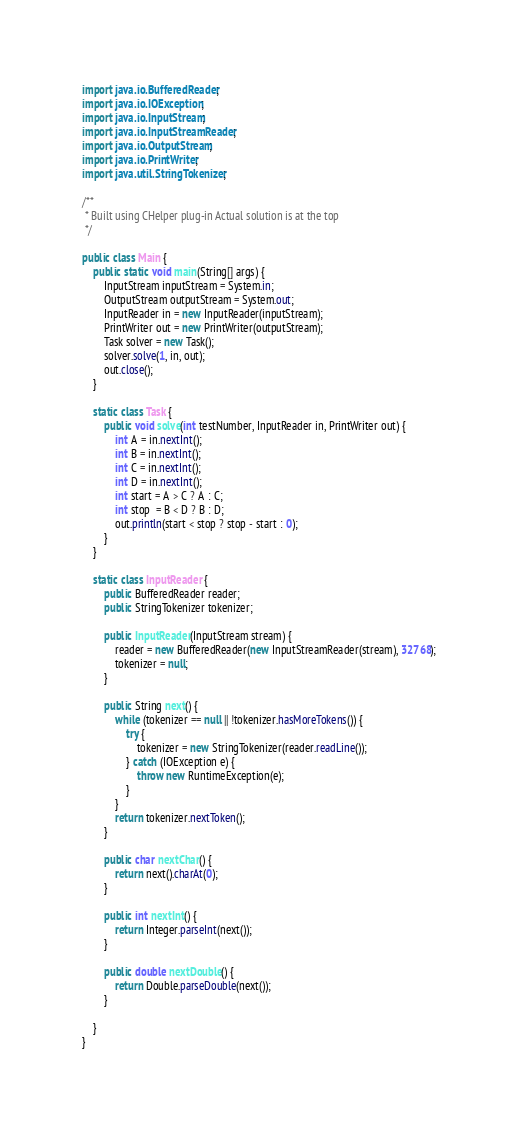<code> <loc_0><loc_0><loc_500><loc_500><_Java_>import java.io.BufferedReader;
import java.io.IOException;
import java.io.InputStream;
import java.io.InputStreamReader;
import java.io.OutputStream;
import java.io.PrintWriter;
import java.util.StringTokenizer;

/**
 * Built using CHelper plug-in Actual solution is at the top
 */

public class Main {
	public static void main(String[] args) {
		InputStream inputStream = System.in;
		OutputStream outputStream = System.out;
		InputReader in = new InputReader(inputStream);
		PrintWriter out = new PrintWriter(outputStream);
		Task solver = new Task();
		solver.solve(1, in, out);
		out.close();
	}

	static class Task {
		public void solve(int testNumber, InputReader in, PrintWriter out) {
			int A = in.nextInt();
			int B = in.nextInt();
			int C = in.nextInt();
			int D = in.nextInt();
			int start = A > C ? A : C;
			int stop  = B < D ? B : D;
			out.println(start < stop ? stop - start : 0);
		}
	}

	static class InputReader {
		public BufferedReader reader;
		public StringTokenizer tokenizer;

		public InputReader(InputStream stream) {
			reader = new BufferedReader(new InputStreamReader(stream), 32768);
			tokenizer = null;
		}

		public String next() {
			while (tokenizer == null || !tokenizer.hasMoreTokens()) {
				try {
					tokenizer = new StringTokenizer(reader.readLine());
				} catch (IOException e) {
					throw new RuntimeException(e);
				}
			}
			return tokenizer.nextToken();
		}
		
		public char nextChar() {
			return next().charAt(0);
		}

		public int nextInt() {
			return Integer.parseInt(next());
		}

		public double nextDouble() {
			return Double.parseDouble(next());
		}

	}
}
</code> 